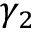Convert formula to latex. <formula><loc_0><loc_0><loc_500><loc_500>\gamma _ { 2 }</formula> 